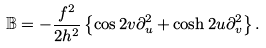<formula> <loc_0><loc_0><loc_500><loc_500>\mathbb { B } = - \frac { f ^ { 2 } } { 2 h ^ { 2 } } \left \{ \cos 2 v \partial ^ { 2 } _ { u } + \cosh 2 u \partial ^ { 2 } _ { v } \right \} .</formula> 